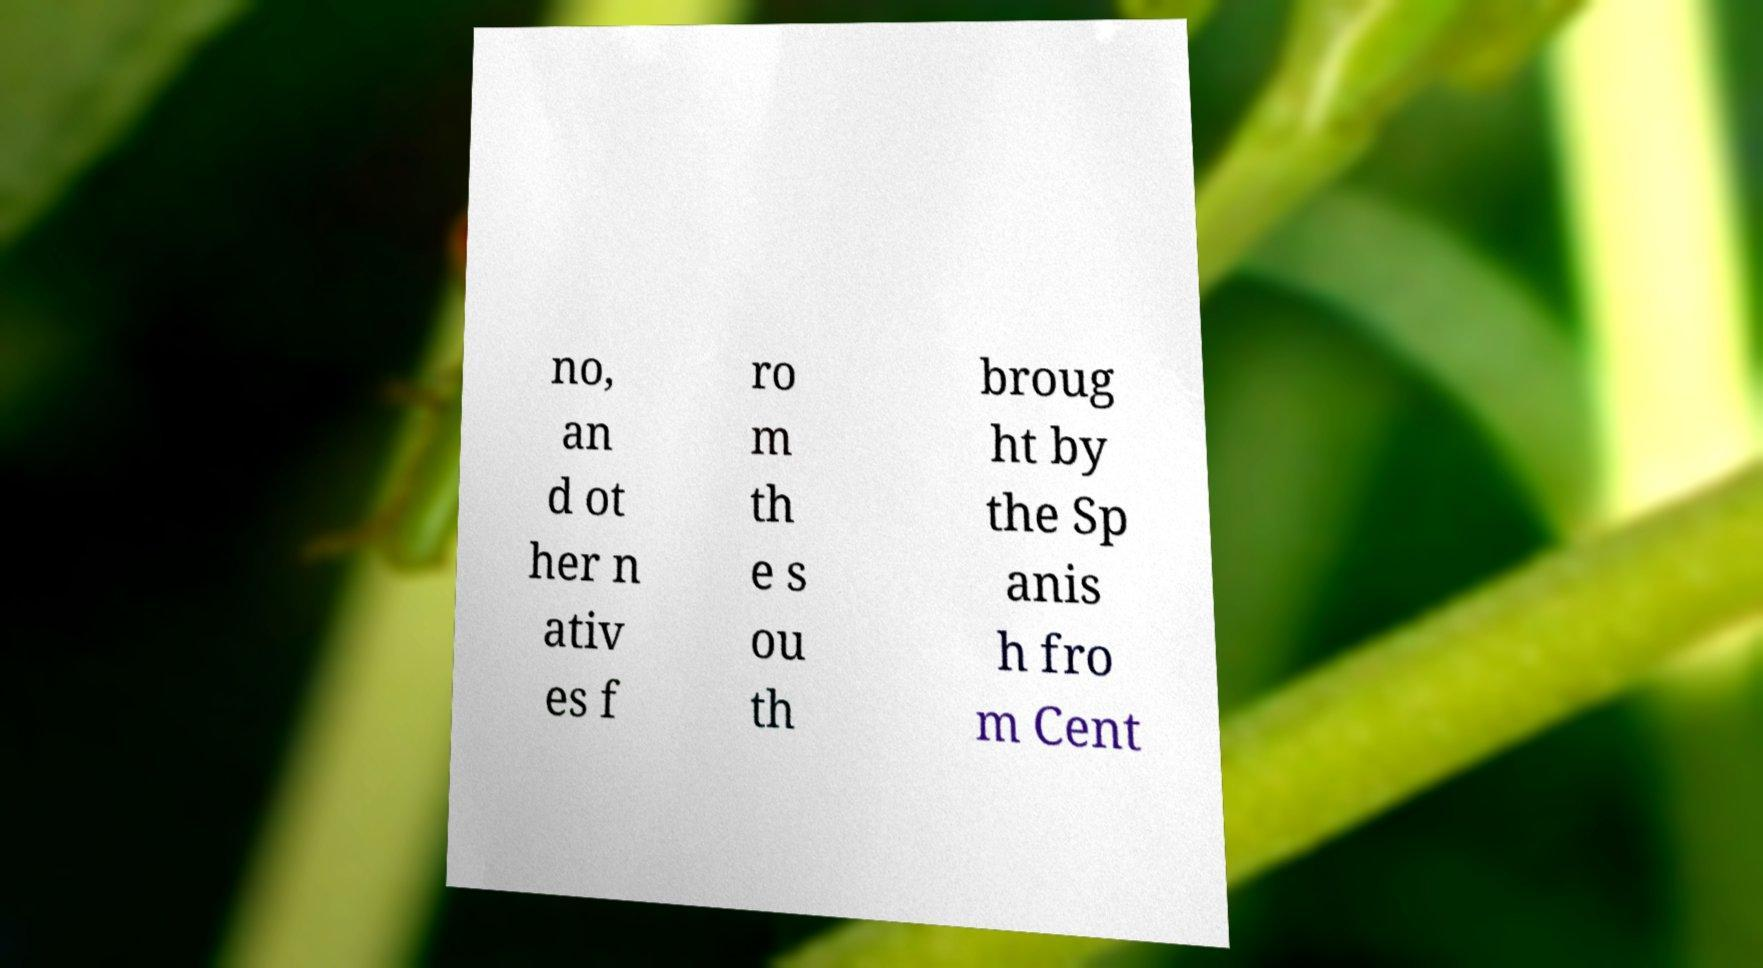Please read and relay the text visible in this image. What does it say? no, an d ot her n ativ es f ro m th e s ou th broug ht by the Sp anis h fro m Cent 